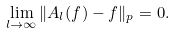<formula> <loc_0><loc_0><loc_500><loc_500>\lim _ { l \to \infty } \| A _ { l } ( f ) - f \| _ { p } = 0 .</formula> 